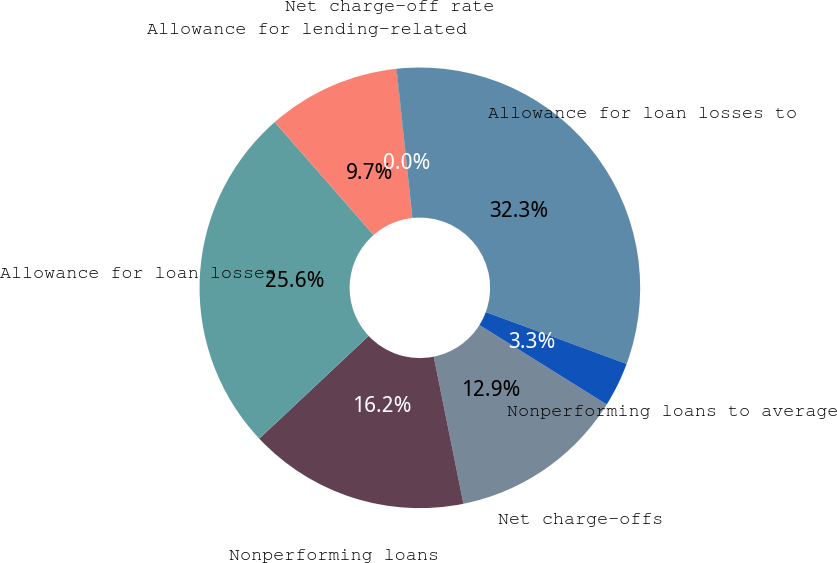Convert chart to OTSL. <chart><loc_0><loc_0><loc_500><loc_500><pie_chart><fcel>Net charge-offs<fcel>Nonperforming loans<fcel>Allowance for loan losses<fcel>Allowance for lending-related<fcel>Net charge-off rate<fcel>Allowance for loan losses to<fcel>Nonperforming loans to average<nl><fcel>12.95%<fcel>16.17%<fcel>25.56%<fcel>9.72%<fcel>0.04%<fcel>32.3%<fcel>3.27%<nl></chart> 